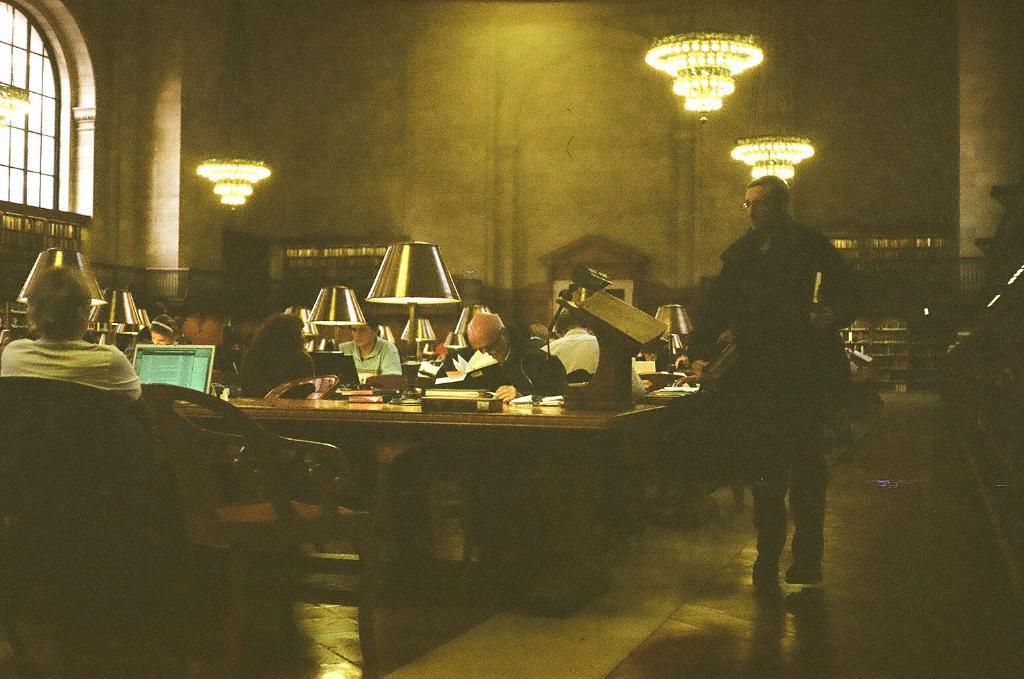What is the general arrangement of people in the room? There is a group of people sitting in a room. Can you describe the position of the person on the right side of the room? There is a person standing on the right side of the room. What is the standing person holding? The standing person is holding a book. What can be seen on the wall in the background of the room? There is a wall in the background of the room, and a curtain is associated with it. What type of branch is being used to stitch the balance in the image? There is no branch, stitching, or balance present in the image. 